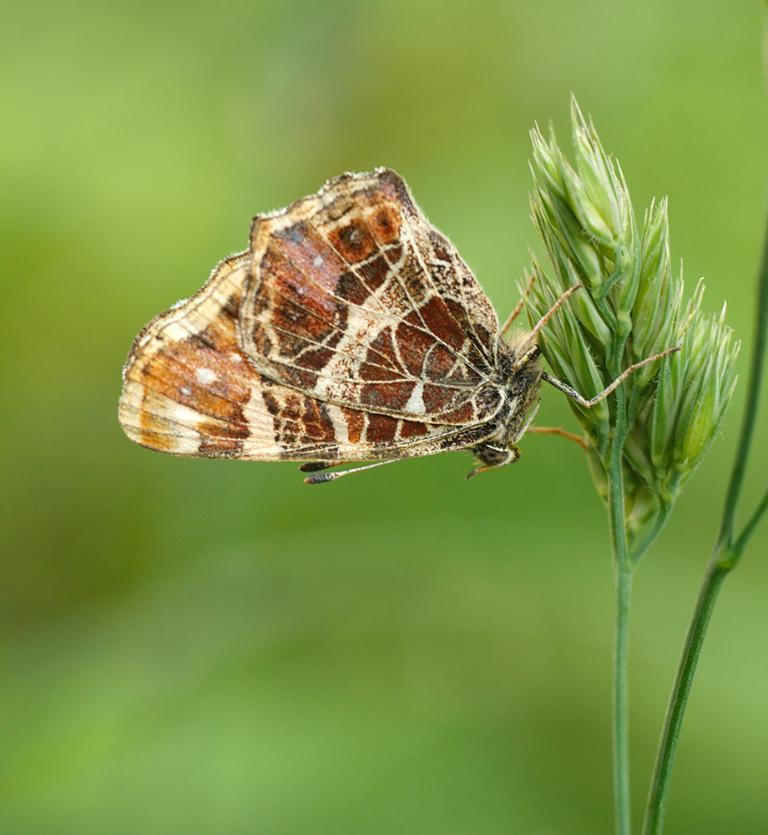What is the main subject of the image? There is a butterfly in the image. Where is the butterfly located? The butterfly is on a plant. Can you describe the background of the image? The background of the image is blurred. What type of respect does the zebra show towards the butterfly in the image? There is no zebra present in the image, so it is not possible to determine any interaction or respect between a zebra and the butterfly. 